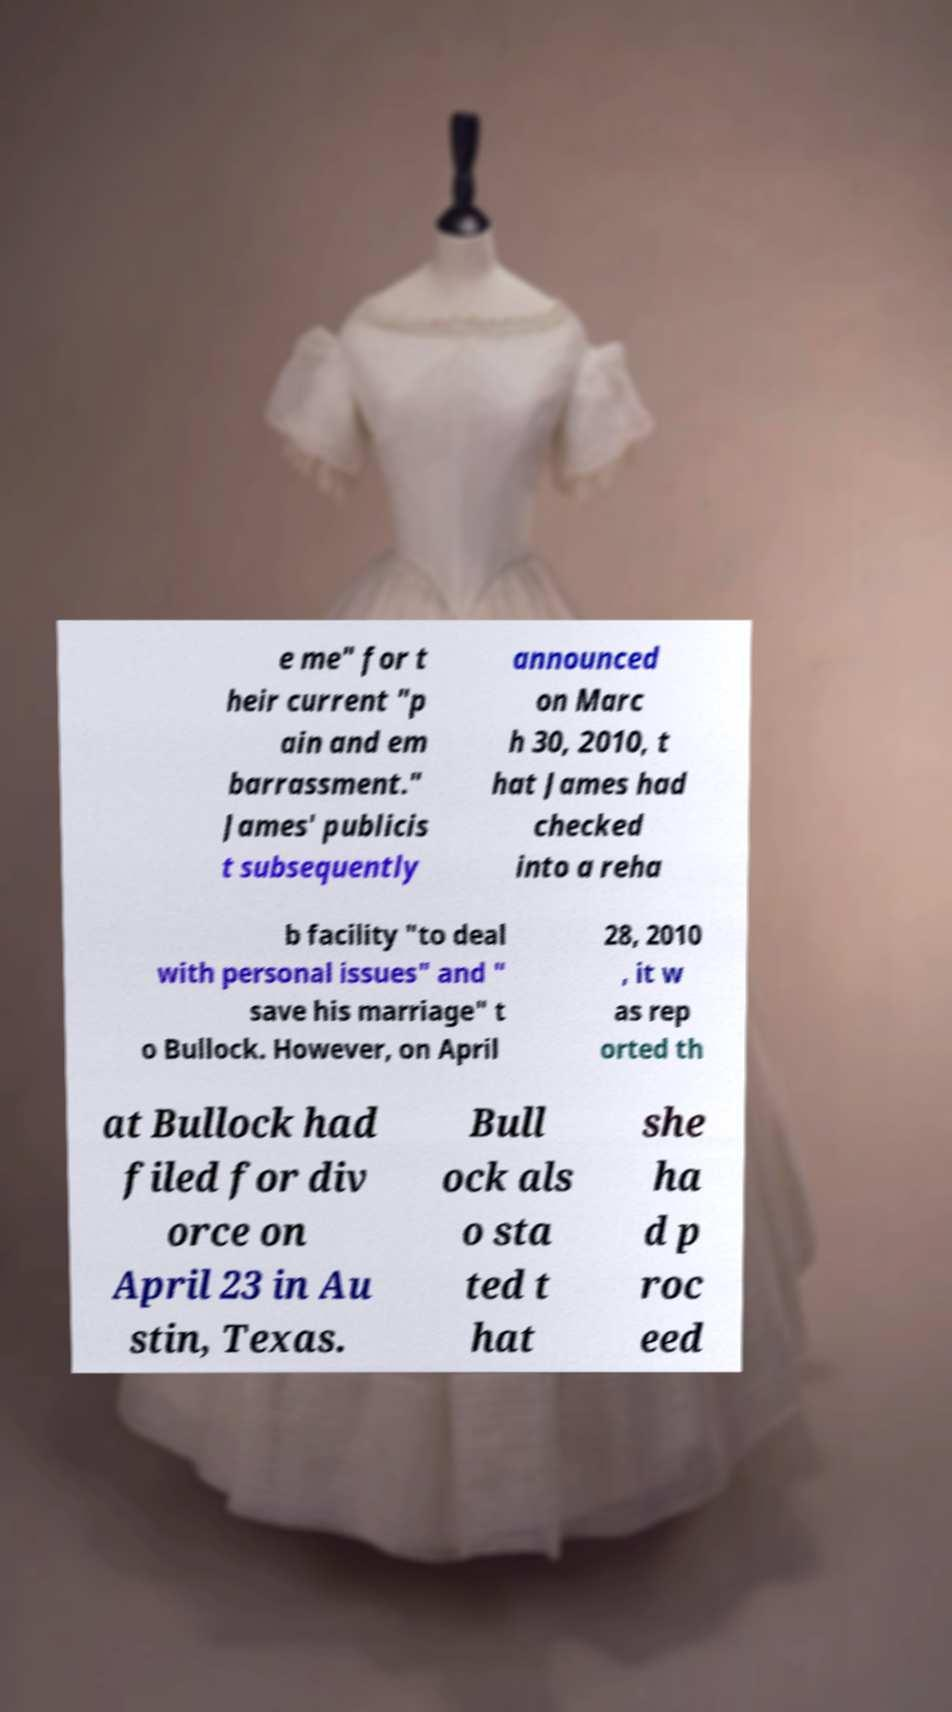Can you read and provide the text displayed in the image?This photo seems to have some interesting text. Can you extract and type it out for me? e me" for t heir current "p ain and em barrassment." James' publicis t subsequently announced on Marc h 30, 2010, t hat James had checked into a reha b facility "to deal with personal issues" and " save his marriage" t o Bullock. However, on April 28, 2010 , it w as rep orted th at Bullock had filed for div orce on April 23 in Au stin, Texas. Bull ock als o sta ted t hat she ha d p roc eed 